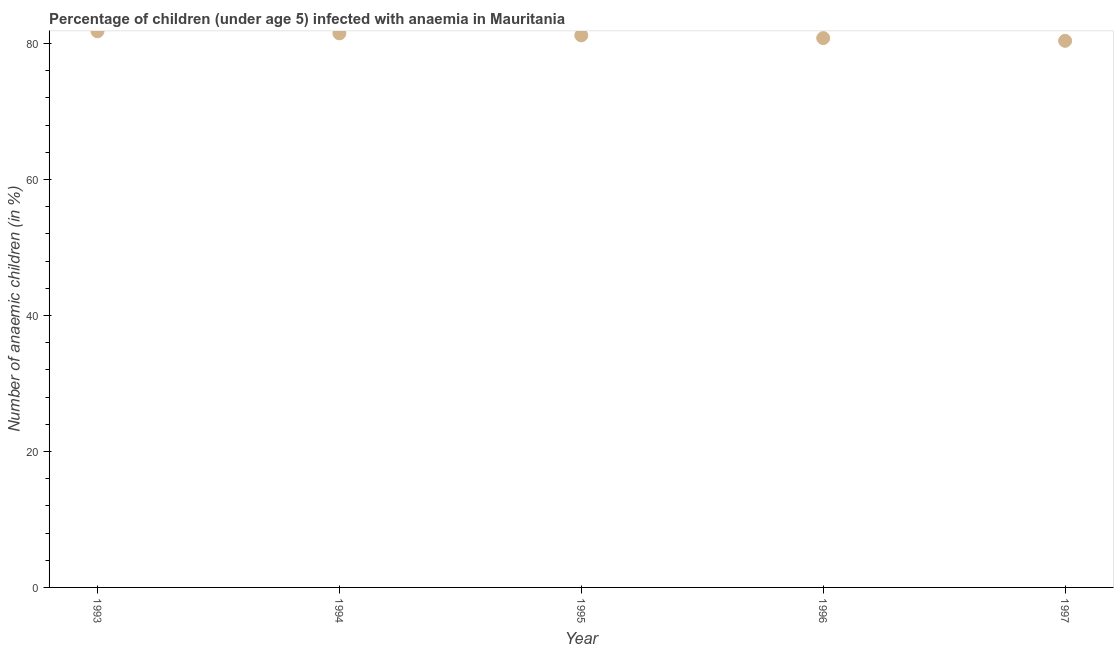What is the number of anaemic children in 1993?
Your answer should be compact. 81.8. Across all years, what is the maximum number of anaemic children?
Keep it short and to the point. 81.8. Across all years, what is the minimum number of anaemic children?
Provide a succinct answer. 80.4. In which year was the number of anaemic children maximum?
Your response must be concise. 1993. In which year was the number of anaemic children minimum?
Offer a terse response. 1997. What is the sum of the number of anaemic children?
Offer a very short reply. 405.7. What is the difference between the number of anaemic children in 1995 and 1996?
Provide a short and direct response. 0.4. What is the average number of anaemic children per year?
Your answer should be very brief. 81.14. What is the median number of anaemic children?
Provide a short and direct response. 81.2. In how many years, is the number of anaemic children greater than 12 %?
Ensure brevity in your answer.  5. Do a majority of the years between 1994 and 1993 (inclusive) have number of anaemic children greater than 24 %?
Your answer should be compact. No. What is the ratio of the number of anaemic children in 1994 to that in 1996?
Your answer should be compact. 1.01. Is the number of anaemic children in 1996 less than that in 1997?
Keep it short and to the point. No. What is the difference between the highest and the second highest number of anaemic children?
Offer a terse response. 0.3. What is the difference between the highest and the lowest number of anaemic children?
Your answer should be very brief. 1.4. Does the number of anaemic children monotonically increase over the years?
Provide a short and direct response. No. How many dotlines are there?
Offer a very short reply. 1. How many years are there in the graph?
Offer a terse response. 5. What is the difference between two consecutive major ticks on the Y-axis?
Your answer should be compact. 20. Does the graph contain any zero values?
Ensure brevity in your answer.  No. What is the title of the graph?
Give a very brief answer. Percentage of children (under age 5) infected with anaemia in Mauritania. What is the label or title of the X-axis?
Provide a short and direct response. Year. What is the label or title of the Y-axis?
Offer a very short reply. Number of anaemic children (in %). What is the Number of anaemic children (in %) in 1993?
Keep it short and to the point. 81.8. What is the Number of anaemic children (in %) in 1994?
Give a very brief answer. 81.5. What is the Number of anaemic children (in %) in 1995?
Make the answer very short. 81.2. What is the Number of anaemic children (in %) in 1996?
Offer a very short reply. 80.8. What is the Number of anaemic children (in %) in 1997?
Provide a short and direct response. 80.4. What is the difference between the Number of anaemic children (in %) in 1993 and 1995?
Your response must be concise. 0.6. What is the difference between the Number of anaemic children (in %) in 1994 and 1995?
Provide a succinct answer. 0.3. What is the difference between the Number of anaemic children (in %) in 1994 and 1997?
Your response must be concise. 1.1. What is the difference between the Number of anaemic children (in %) in 1995 and 1996?
Provide a succinct answer. 0.4. What is the difference between the Number of anaemic children (in %) in 1996 and 1997?
Your answer should be compact. 0.4. What is the ratio of the Number of anaemic children (in %) in 1993 to that in 1995?
Your answer should be very brief. 1.01. What is the ratio of the Number of anaemic children (in %) in 1993 to that in 1996?
Ensure brevity in your answer.  1.01. What is the ratio of the Number of anaemic children (in %) in 1993 to that in 1997?
Your answer should be very brief. 1.02. What is the ratio of the Number of anaemic children (in %) in 1994 to that in 1995?
Give a very brief answer. 1. What is the ratio of the Number of anaemic children (in %) in 1994 to that in 1996?
Make the answer very short. 1.01. What is the ratio of the Number of anaemic children (in %) in 1995 to that in 1996?
Give a very brief answer. 1. 